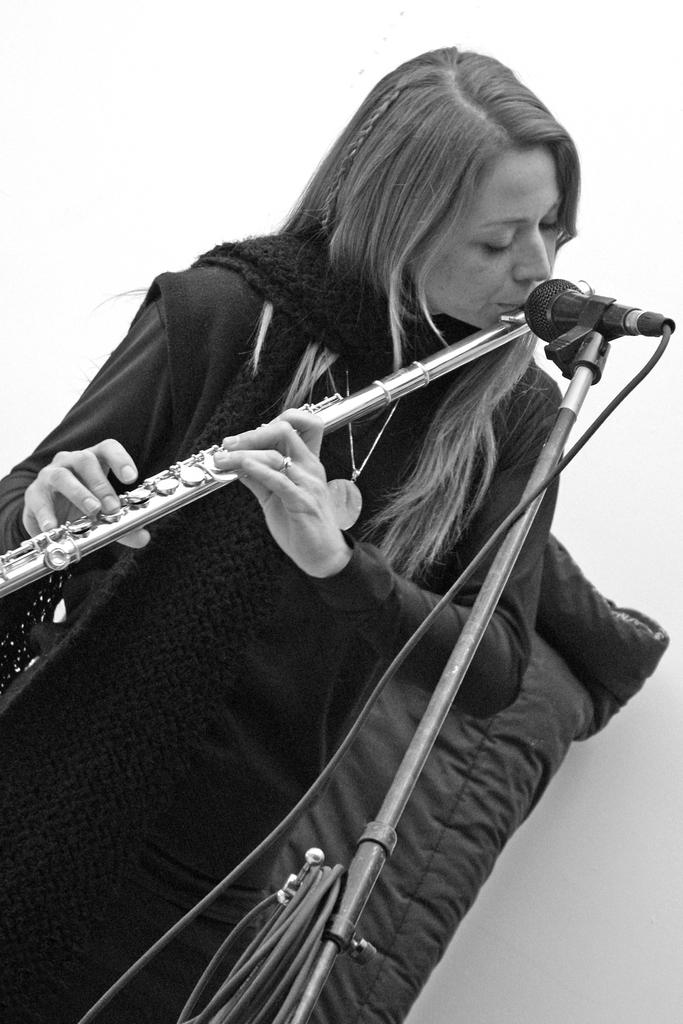Who is the main subject in the image? There is a lady in the image. the image. What is the lady doing in the image? The lady is playing a flute. What is placed in front of the lady? There is a microphone in front of the lady. What accessories is the lady wearing in the image? The lady is wearing a scarf and a jacket. What type of beast can be seen tangled in a net in the image? There is no beast or net present in the image; it features a lady playing a flute with a microphone in front of her. What flavor of jam is the lady spreading on her toast in the image? There is no toast or jam present in the image; the lady is playing a flute and wearing a scarf and jacket. 